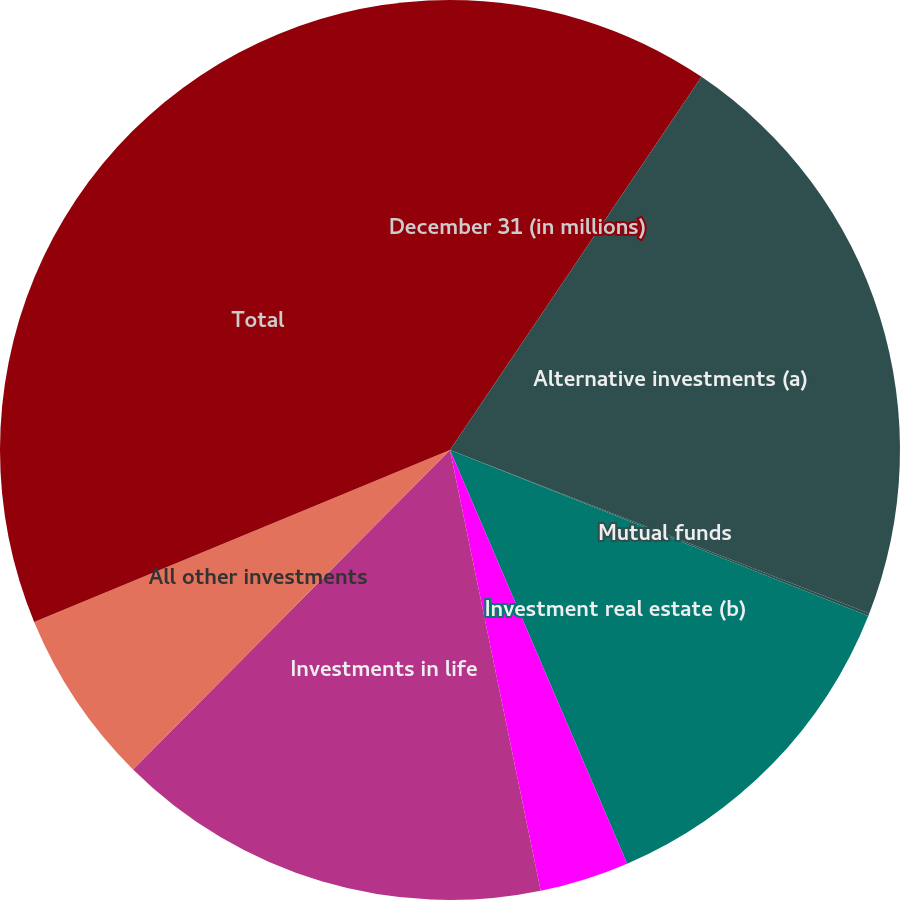<chart> <loc_0><loc_0><loc_500><loc_500><pie_chart><fcel>December 31 (in millions)<fcel>Alternative investments (a)<fcel>Mutual funds<fcel>Investment real estate (b)<fcel>Aircraft asset investments (c)<fcel>Investments in life<fcel>All other investments<fcel>Total<nl><fcel>9.44%<fcel>21.48%<fcel>0.09%<fcel>12.55%<fcel>3.21%<fcel>15.67%<fcel>6.32%<fcel>31.24%<nl></chart> 